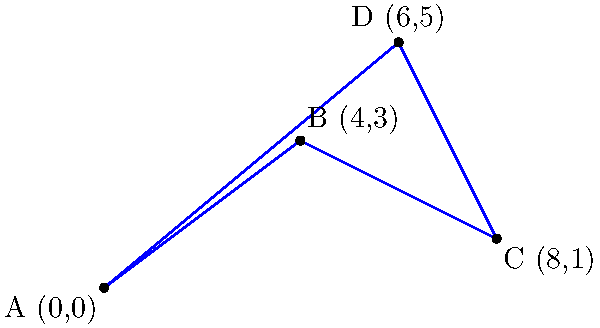As a transportation commissioner, you are tasked with designing the most efficient subway route connecting four major stations in the city. The stations are represented as points A(0,0), B(4,3), C(8,1), and D(6,5) on a coordinate plane. What is the total length of the shortest possible route that connects all four stations? To find the shortest possible route connecting all four stations, we need to calculate the total length of the sides of the quadrilateral ABCD. This is because any other path would be longer than the direct connections between the points.

Step 1: Calculate the length of AB
$AB = \sqrt{(x_B - x_A)^2 + (y_B - y_A)^2} = \sqrt{(4-0)^2 + (3-0)^2} = \sqrt{16 + 9} = \sqrt{25} = 5$

Step 2: Calculate the length of BC
$BC = \sqrt{(x_C - x_B)^2 + (y_C - y_B)^2} = \sqrt{(8-4)^2 + (1-3)^2} = \sqrt{16 + 4} = \sqrt{20} = 2\sqrt{5}$

Step 3: Calculate the length of CD
$CD = \sqrt{(x_D - x_C)^2 + (y_D - y_C)^2} = \sqrt{(6-8)^2 + (5-1)^2} = \sqrt{4 + 16} = \sqrt{20} = 2\sqrt{5}$

Step 4: Calculate the length of DA
$DA = \sqrt{(x_A - x_D)^2 + (y_A - y_D)^2} = \sqrt{(0-6)^2 + (0-5)^2} = \sqrt{36 + 25} = \sqrt{61}$

Step 5: Sum up all the lengths
Total length = $AB + BC + CD + DA = 5 + 2\sqrt{5} + 2\sqrt{5} + \sqrt{61}$

Step 6: Simplify
Total length = $5 + 4\sqrt{5} + \sqrt{61}$
Answer: $5 + 4\sqrt{5} + \sqrt{61}$ 